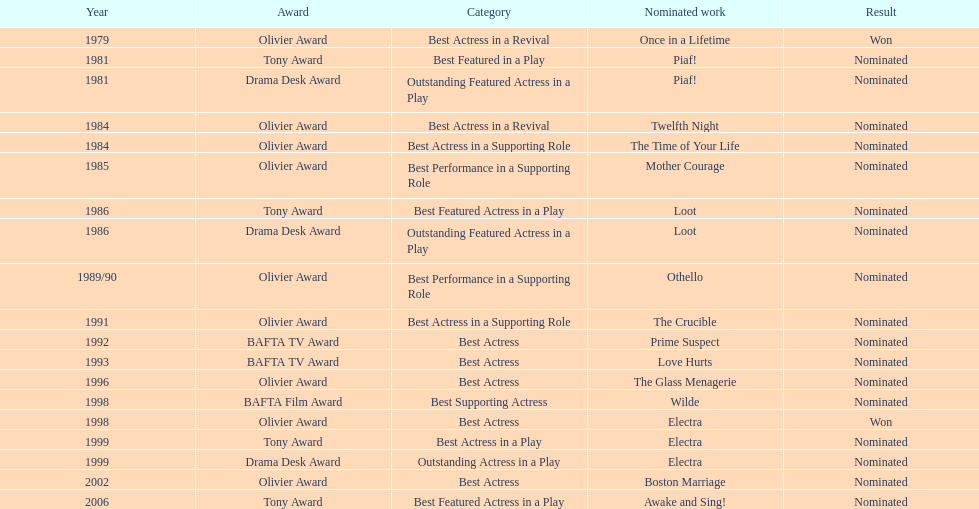In 1981, what play earned wanamaker a nomination for best featured in a play? Piaf!. 